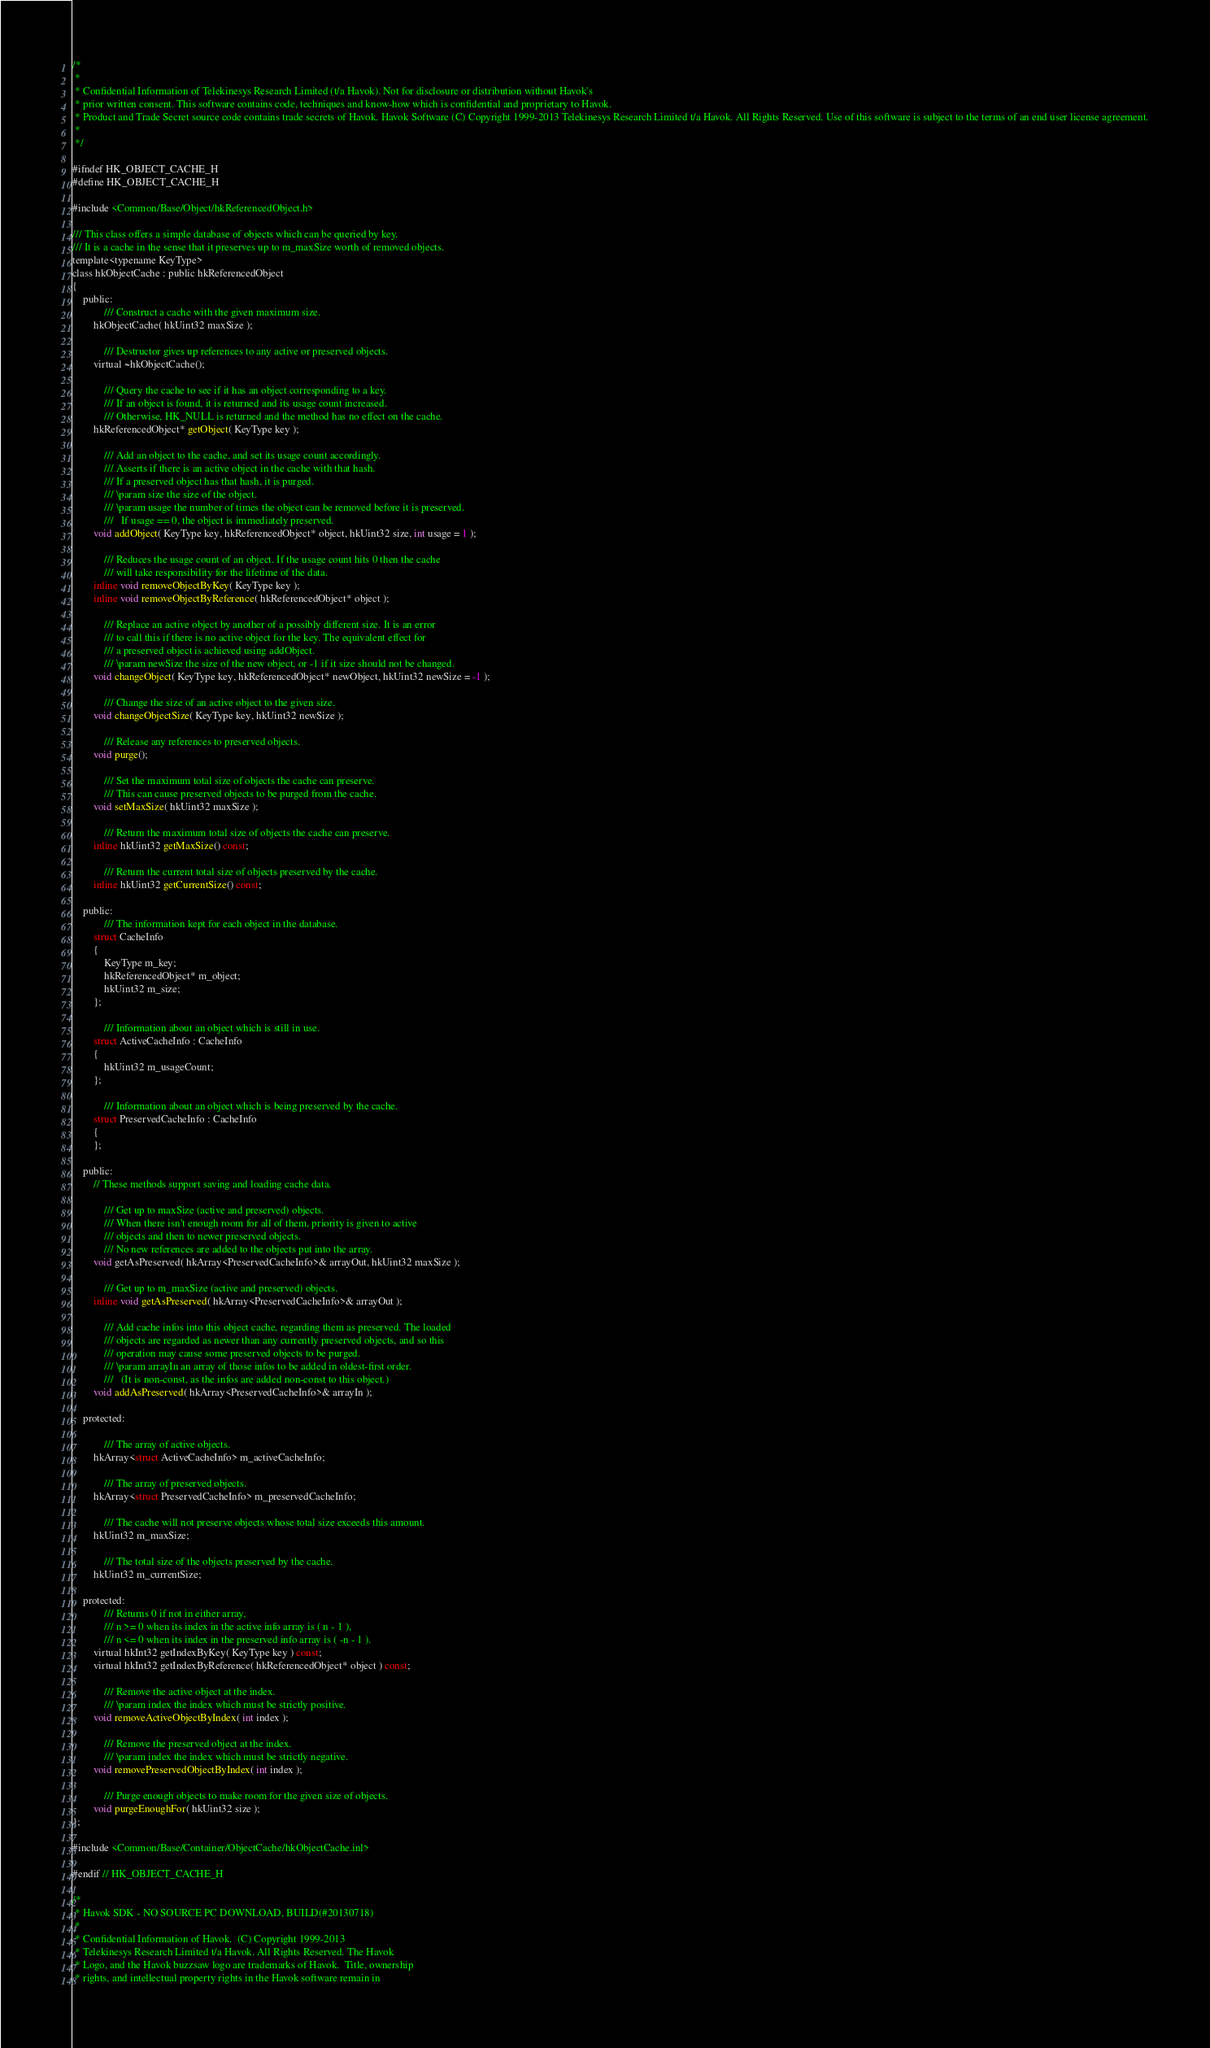<code> <loc_0><loc_0><loc_500><loc_500><_C_>/*
 *
 * Confidential Information of Telekinesys Research Limited (t/a Havok). Not for disclosure or distribution without Havok's
 * prior written consent. This software contains code, techniques and know-how which is confidential and proprietary to Havok.
 * Product and Trade Secret source code contains trade secrets of Havok. Havok Software (C) Copyright 1999-2013 Telekinesys Research Limited t/a Havok. All Rights Reserved. Use of this software is subject to the terms of an end user license agreement.
 *
 */

#ifndef HK_OBJECT_CACHE_H
#define HK_OBJECT_CACHE_H

#include <Common/Base/Object/hkReferencedObject.h>

/// This class offers a simple database of objects which can be queried by key.
/// It is a cache in the sense that it preserves up to m_maxSize worth of removed objects.
template<typename KeyType>
class hkObjectCache : public hkReferencedObject
{
	public:
			/// Construct a cache with the given maximum size.
		hkObjectCache( hkUint32 maxSize );

			/// Destructor gives up references to any active or preserved objects.
		virtual ~hkObjectCache();

			/// Query the cache to see if it has an object corresponding to a key.
			/// If an object is found, it is returned and its usage count increased.
			/// Otherwise, HK_NULL is returned and the method has no effect on the cache.
		hkReferencedObject* getObject( KeyType key );

			/// Add an object to the cache, and set its usage count accordingly.
			/// Asserts if there is an active object in the cache with that hash.
			/// If a preserved object has that hash, it is purged.
			/// \param size the size of the object.
			/// \param usage the number of times the object can be removed before it is preserved.
			///   If usage == 0, the object is immediately preserved.
		void addObject( KeyType key, hkReferencedObject* object, hkUint32 size, int usage = 1 );

			/// Reduces the usage count of an object. If the usage count hits 0 then the cache
			/// will take responsibility for the lifetime of the data.
		inline void removeObjectByKey( KeyType key );
		inline void removeObjectByReference( hkReferencedObject* object );

			/// Replace an active object by another of a possibly different size. It is an error
			/// to call this if there is no active object for the key. The equivalent effect for
			/// a preserved object is achieved using addObject.
			/// \param newSize the size of the new object, or -1 if it size should not be changed.
		void changeObject( KeyType key, hkReferencedObject* newObject, hkUint32 newSize = -1 );

			/// Change the size of an active object to the given size.
		void changeObjectSize( KeyType key, hkUint32 newSize );

			/// Release any references to preserved objects.
		void purge();

			/// Set the maximum total size of objects the cache can preserve.
			/// This can cause preserved objects to be purged from the cache.
		void setMaxSize( hkUint32 maxSize );

			/// Return the maximum total size of objects the cache can preserve.
		inline hkUint32 getMaxSize() const;

			/// Return the current total size of objects preserved by the cache.
		inline hkUint32 getCurrentSize() const;

	public:
			/// The information kept for each object in the database.
		struct CacheInfo 
		{
			KeyType m_key;
			hkReferencedObject* m_object;
			hkUint32 m_size;
		};

			/// Information about an object which is still in use.
		struct ActiveCacheInfo : CacheInfo
		{
			hkUint32 m_usageCount;
		};

			/// Information about an object which is being preserved by the cache.
		struct PreservedCacheInfo : CacheInfo
		{
		};

	public:
		// These methods support saving and loading cache data.

			/// Get up to maxSize (active and preserved) objects.
			/// When there isn't enough room for all of them, priority is given to active
			/// objects and then to newer preserved objects.
			/// No new references are added to the objects put into the array.
		void getAsPreserved( hkArray<PreservedCacheInfo>& arrayOut, hkUint32 maxSize );

			/// Get up to m_maxSize (active and preserved) objects.
		inline void getAsPreserved( hkArray<PreservedCacheInfo>& arrayOut );

			/// Add cache infos into this object cache, regarding them as preserved. The loaded
			/// objects are regarded as newer than any currently preserved objects, and so this
			/// operation may cause some preserved objects to be purged.
			/// \param arrayIn an array of those infos to be added in oldest-first order.
			///   (It is non-const, as the infos are added non-const to this object.)
		void addAsPreserved( hkArray<PreservedCacheInfo>& arrayIn );

	protected:

			/// The array of active objects.
		hkArray<struct ActiveCacheInfo> m_activeCacheInfo;

			/// The array of preserved objects.
		hkArray<struct PreservedCacheInfo> m_preservedCacheInfo;

			/// The cache will not preserve objects whose total size exceeds this amount.
		hkUint32 m_maxSize;

			/// The total size of the objects preserved by the cache.
		hkUint32 m_currentSize;

	protected:
			/// Returns 0 if not in either array,
			///	n >= 0 when its index in the active info array is ( n - 1 ),
			///	n <= 0 when its index in the preserved info array is ( -n - 1 ).
		virtual hkInt32 getIndexByKey( KeyType key ) const;
		virtual hkInt32 getIndexByReference( hkReferencedObject* object ) const;

			/// Remove the active object at the index.
			/// \param index the index which must be strictly positive.
		void removeActiveObjectByIndex( int index );

			/// Remove the preserved object at the index.
			/// \param index the index which must be strictly negative.
		void removePreservedObjectByIndex( int index );

			/// Purge enough objects to make room for the given size of objects.
		void purgeEnoughFor( hkUint32 size );	
};

#include <Common/Base/Container/ObjectCache/hkObjectCache.inl>

#endif // HK_OBJECT_CACHE_H

/*
 * Havok SDK - NO SOURCE PC DOWNLOAD, BUILD(#20130718)
 * 
 * Confidential Information of Havok.  (C) Copyright 1999-2013
 * Telekinesys Research Limited t/a Havok. All Rights Reserved. The Havok
 * Logo, and the Havok buzzsaw logo are trademarks of Havok.  Title, ownership
 * rights, and intellectual property rights in the Havok software remain in</code> 